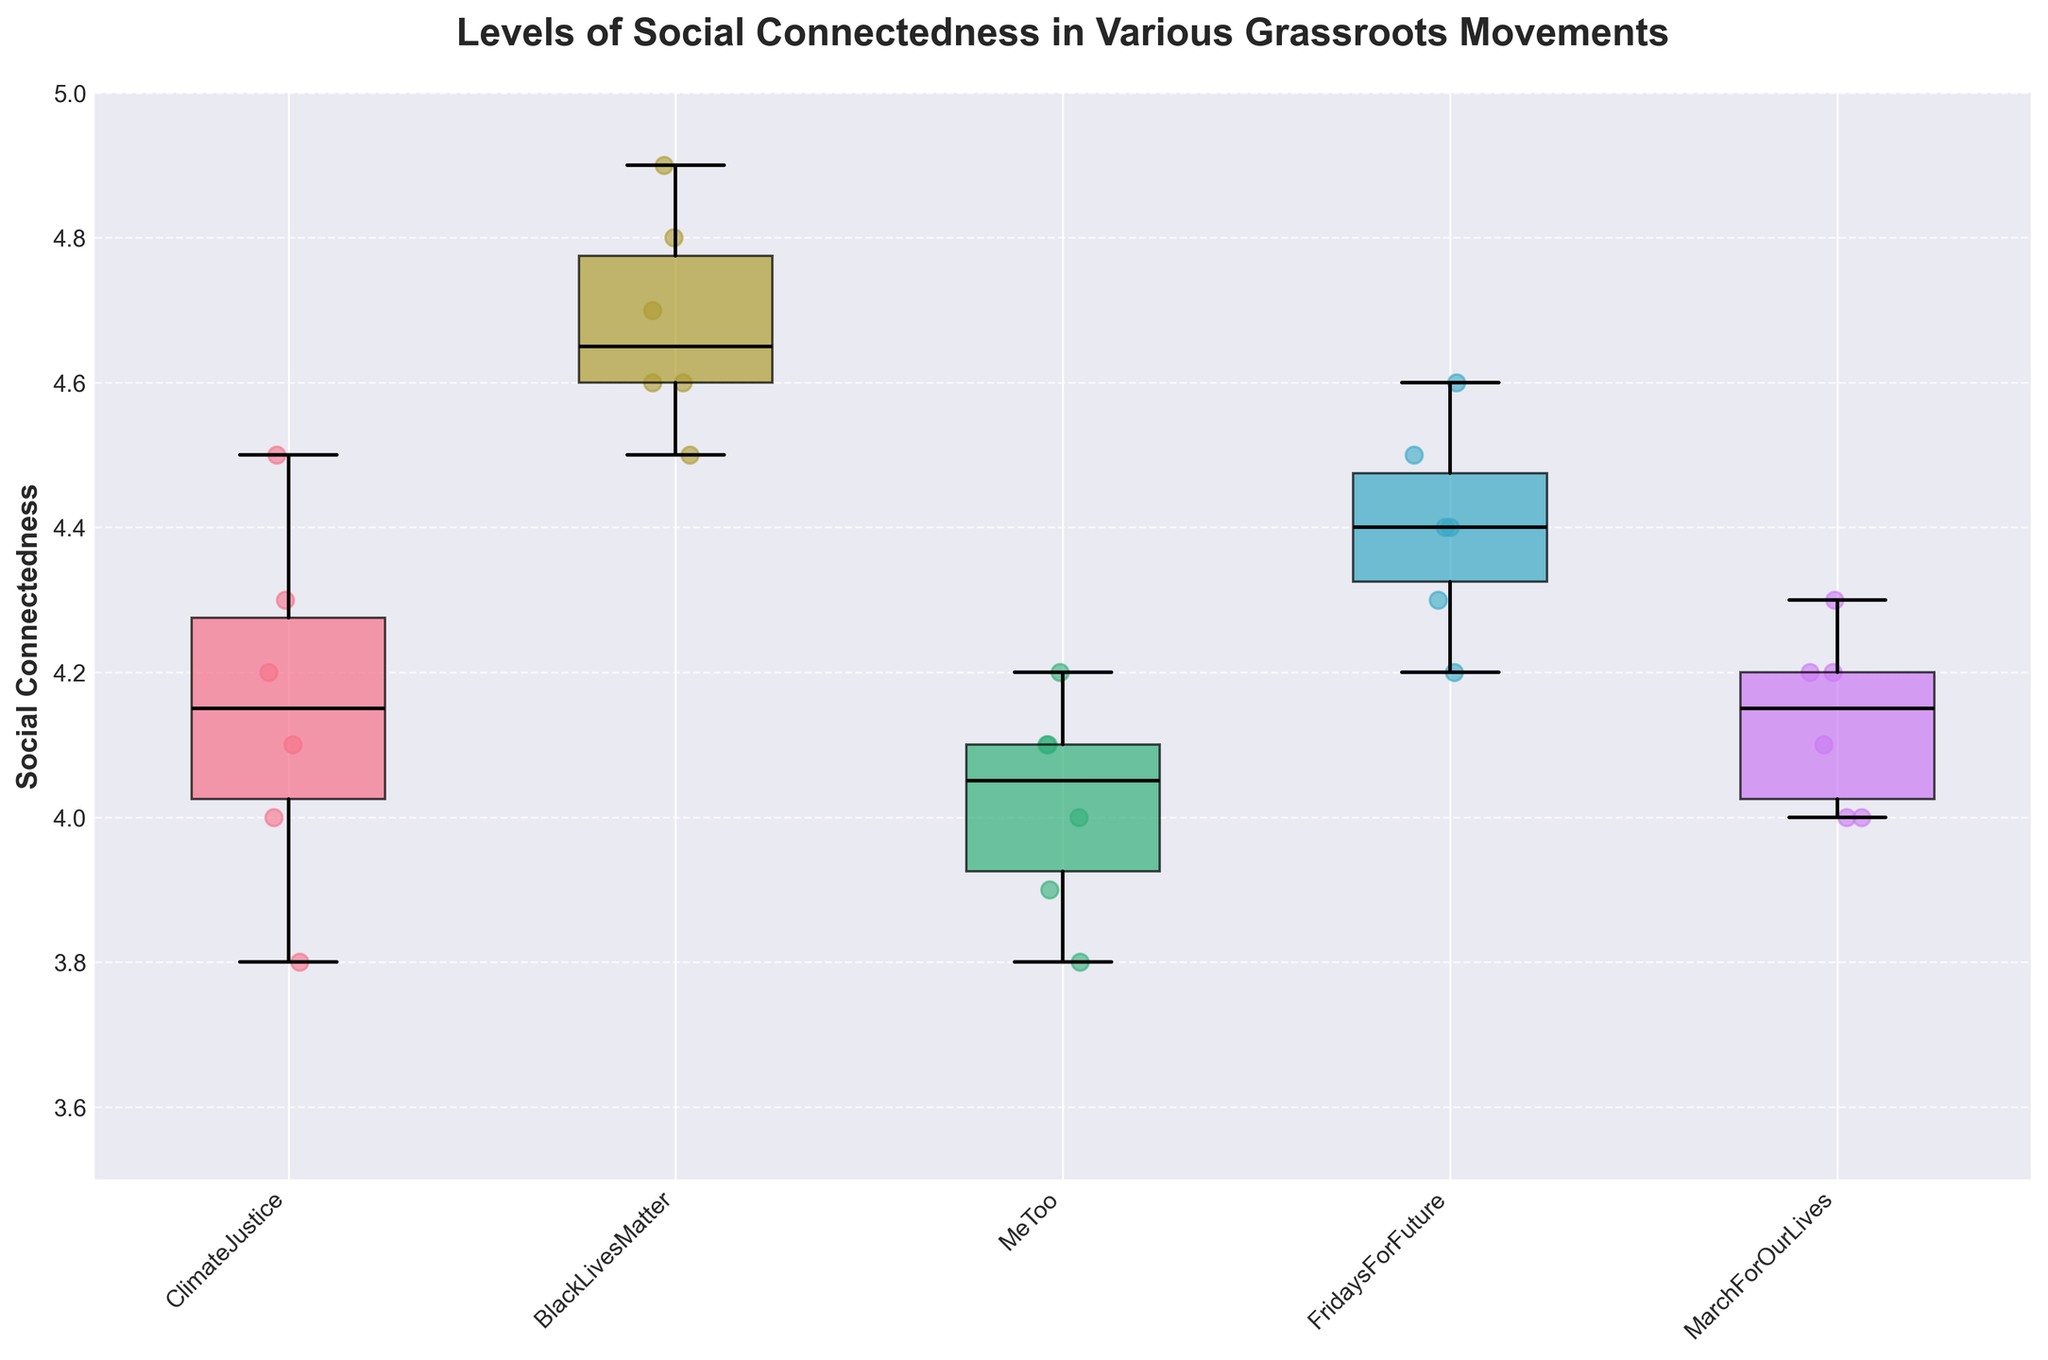What is the title of the figure? The title is displayed at the top of the figure, which reads "Levels of Social Connectedness in Various Grassroots Movements."
Answer: Levels of Social Connectedness in Various Grassroots Movements What is the range of the y-axis for Social Connectedness? The y-axis range can be observed from the scale on the left side of the plot, which ranges from 3.5 to 5.0.
Answer: 3.5 to 5.0 How many different grassroots movements are represented in the figure? By counting the number of unique labels on the x-axis, we can determine there are five different grassroots movements.
Answer: Five Which grassroots movement has the highest median Social Connectedness? The box plot for each movement shows the median as a black line inside the box. The movement with the highest median line is "BlackLivesMatter."
Answer: BlackLivesMatter Compare the interquartile ranges (IQRs) of "ClimateJustice" and "MeToo" movements. Which one is larger? The IQR is the range between the first quartile (bottom of the box) and the third quartile (top of the box). By comparing the heights of the boxes for "ClimateJustice" and "MeToo," we see that "ClimateJustice" has a slightly larger IQR.
Answer: ClimateJustice Which grassroots movement shows the most variability in Social Connectedness scores? The range between the whiskers and outliers indicates variability. "MarchForOurLives" shows the most variability as it has a wider spread between the whiskers.
Answer: MarchForOurLives Are there any outliers in the Social Connectedness data across the grassroots movements? An outlier would appear as a point outside the whiskers of the box plots. In this figure, there are no outliers visible in any of the movements.
Answer: No What is the approximate median Social Connectedness score for "FridaysForFuture"? The median value is represented by the horizontal black line within the box plot. For "FridaysForFuture," the median is approximately 4.4.
Answer: 4.4 Which grassroots movement has the lowest minimum Social Connectedness value? The minimum value is denoted by the bottom whisker of the boxplot. "MeToo" has the lowest minimum value, around 3.8.
Answer: MeToo How do the medians of "ClimateJustice" and "MarchForOurLives" compare? The median values are shown by the black line in each box plot. Comparing the two, "ClimateJustice" has a slightly higher median than "MarchForOurLives."
Answer: ClimateJustice 